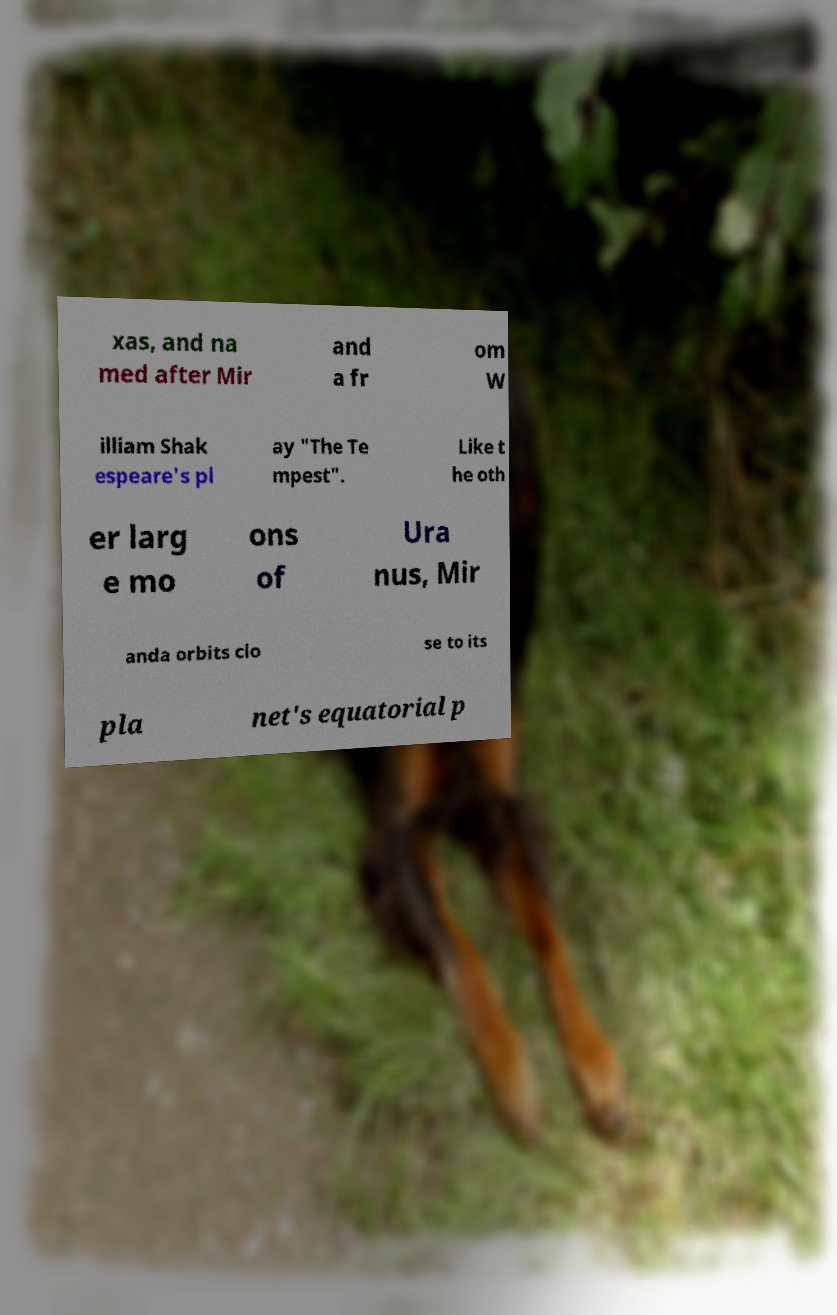Please identify and transcribe the text found in this image. xas, and na med after Mir and a fr om W illiam Shak espeare's pl ay "The Te mpest". Like t he oth er larg e mo ons of Ura nus, Mir anda orbits clo se to its pla net's equatorial p 